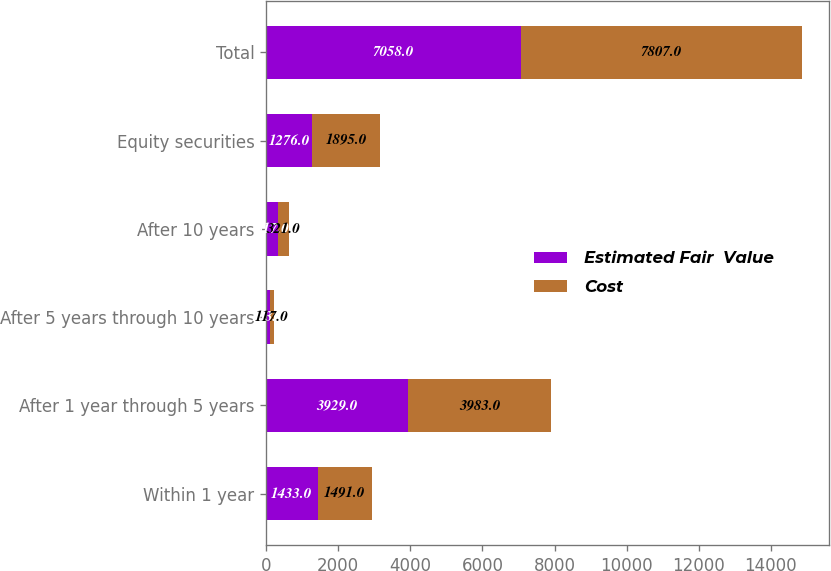Convert chart. <chart><loc_0><loc_0><loc_500><loc_500><stacked_bar_chart><ecel><fcel>Within 1 year<fcel>After 1 year through 5 years<fcel>After 5 years through 10 years<fcel>After 10 years<fcel>Equity securities<fcel>Total<nl><fcel>Estimated Fair  Value<fcel>1433<fcel>3929<fcel>103<fcel>317<fcel>1276<fcel>7058<nl><fcel>Cost<fcel>1491<fcel>3983<fcel>117<fcel>321<fcel>1895<fcel>7807<nl></chart> 